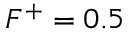<formula> <loc_0><loc_0><loc_500><loc_500>F ^ { + } = 0 . 5</formula> 